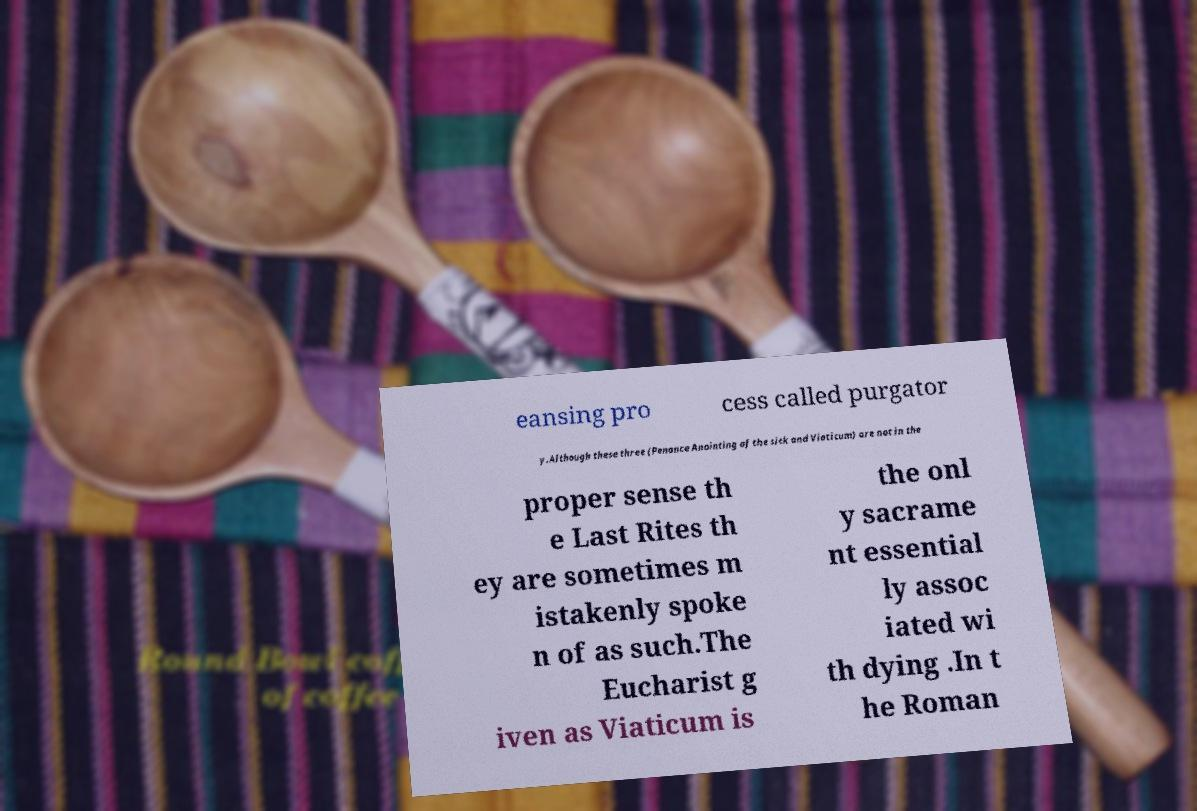There's text embedded in this image that I need extracted. Can you transcribe it verbatim? eansing pro cess called purgator y.Although these three (Penance Anointing of the sick and Viaticum) are not in the proper sense th e Last Rites th ey are sometimes m istakenly spoke n of as such.The Eucharist g iven as Viaticum is the onl y sacrame nt essential ly assoc iated wi th dying .In t he Roman 